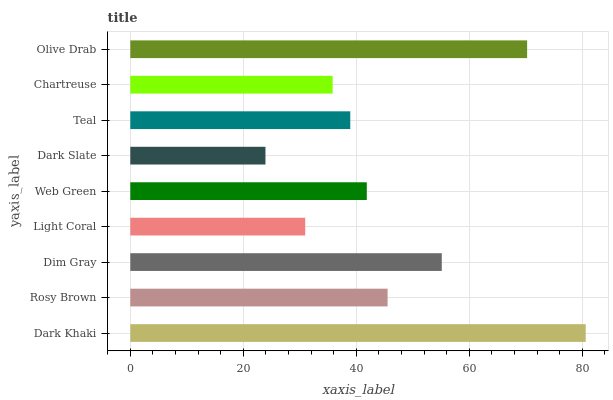Is Dark Slate the minimum?
Answer yes or no. Yes. Is Dark Khaki the maximum?
Answer yes or no. Yes. Is Rosy Brown the minimum?
Answer yes or no. No. Is Rosy Brown the maximum?
Answer yes or no. No. Is Dark Khaki greater than Rosy Brown?
Answer yes or no. Yes. Is Rosy Brown less than Dark Khaki?
Answer yes or no. Yes. Is Rosy Brown greater than Dark Khaki?
Answer yes or no. No. Is Dark Khaki less than Rosy Brown?
Answer yes or no. No. Is Web Green the high median?
Answer yes or no. Yes. Is Web Green the low median?
Answer yes or no. Yes. Is Dark Slate the high median?
Answer yes or no. No. Is Chartreuse the low median?
Answer yes or no. No. 